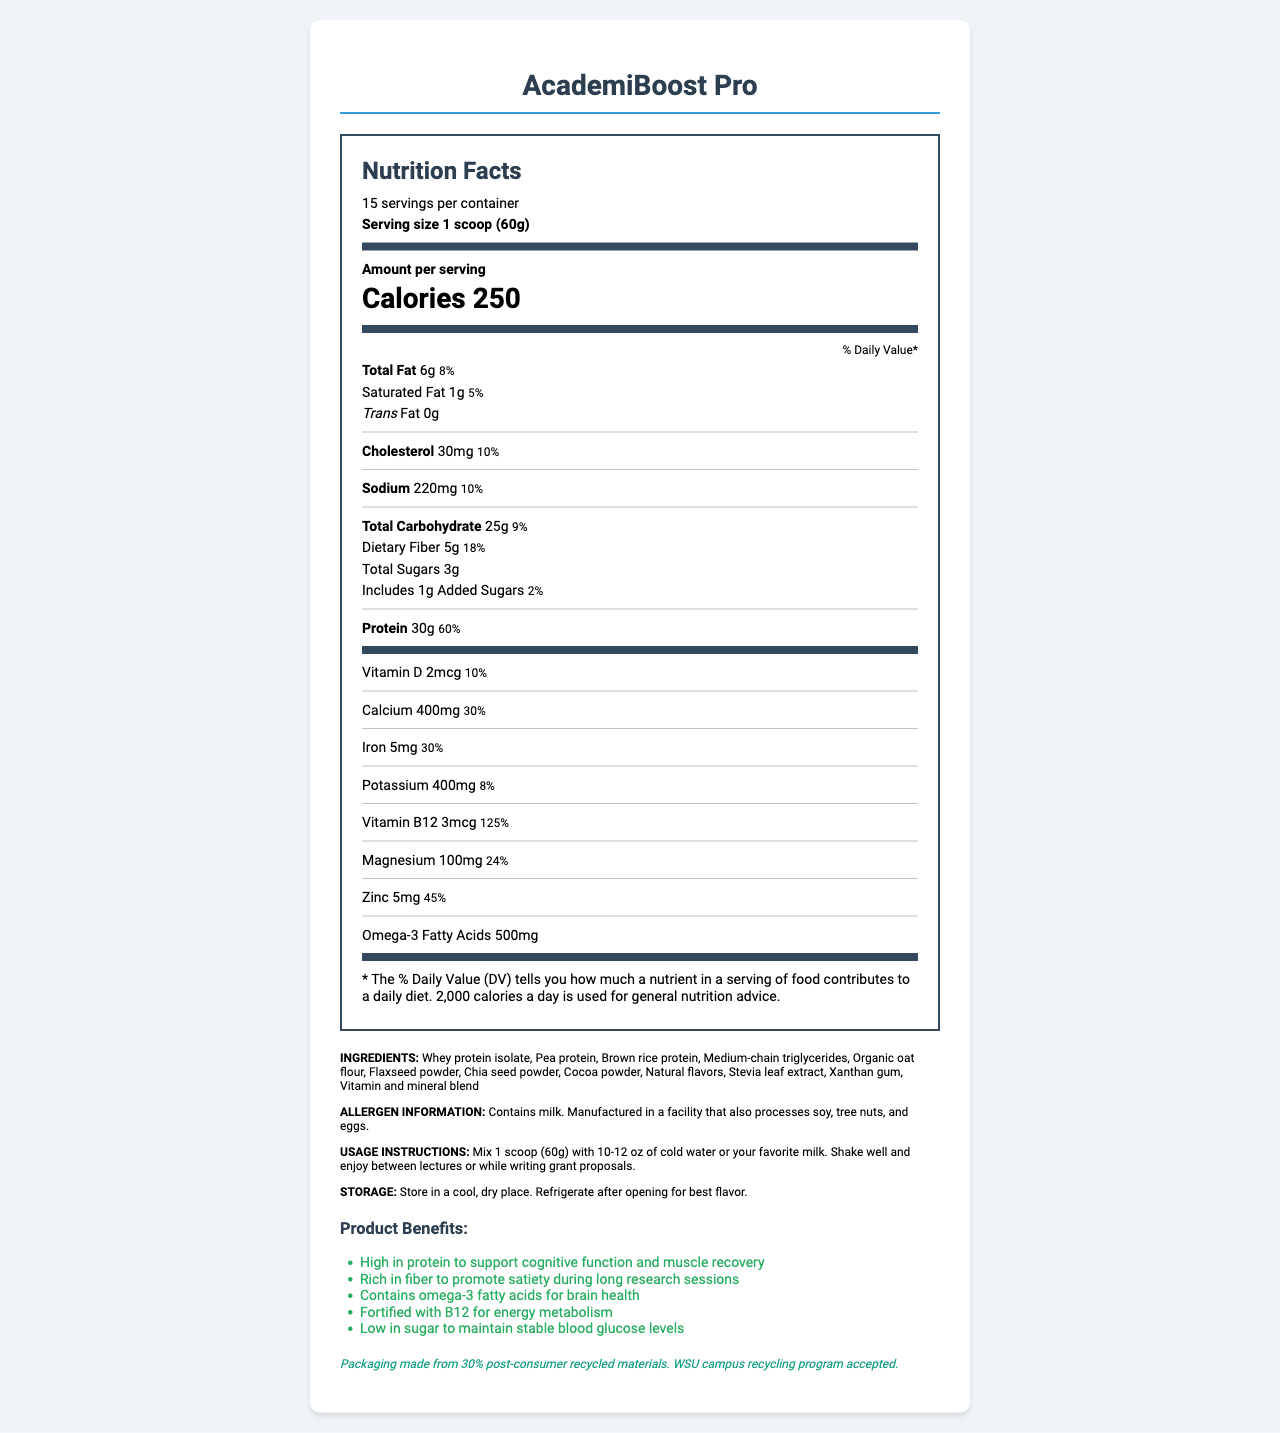what is the serving size of AcademiBoost Pro? The serving size is stated as "1 scoop (60g)" on the Nutrition Facts Label.
Answer: 1 scoop (60g) how many servings are there per container? The document mentions that there are 15 servings per container.
Answer: 15 servings per container how many calories are there per serving? The amount per serving is indicated as 250 calories.
Answer: 250 calories what is the amount of protein per serving and its daily value percentage? The label shows that each serving has 30g of protein, which is 60% of the daily value.
Answer: 30g, 60% which vitamin has the highest daily value percentage in a serving? The Nutrition Facts Label shows Vitamin B12 at 125% daily value, the highest among listed vitamins.
Answer: Vitamin B12 contains milk. Manufactured in a facility that also processes which allergens? A. Shellfish, Wheat, Eggs B. Soy, Shellfish, Milk C. Soy, Tree nuts, Eggs The label indicates "Contains milk. Manufactured in a facility that also processes soy, tree nuts, and eggs."
Answer: C what amount of added sugars does one serving contain? According to the Nutrition Facts Label, there is 1g of added sugars per serving.
Answer: 1g which ingredient is not present in AcademiBoost Pro? A. Flaxseed powder B. Almond milk C. Pea protein Almond milk is not listed among the ingredients, but Flaxseed powder and Pea protein are included.
Answer: B is AcademiBoost Pro fortified with Vitamin D? The document lists Vitamin D as one of the vitamins, with a daily value of 10%.
Answer: Yes describe the main benefits of AcademiBoost Pro for busy academics. The document outlines several main benefits, including high protein for cognitive function and muscle recovery, fiber for satiety, omega-3s for brain health, B12 for energy, and low sugar for stable blood glucose.
Answer: AcademiBoost Pro is high in protein to support cognitive function and muscle recovery, rich in fiber to promote satiety, contains omega-3 fatty acids for brain health, fortified with B12 for energy metabolism, and low in sugar to maintain stable blood glucose levels. what is the source of omega-3 fatty acids in AcademiBoost Pro? The document mentions that there are omega-3 fatty acids present but does not specify the source.
Answer: Not enough information how much cholesterol does one serving of AcademiBoost Pro contain? The Nutrition Facts label shows that one serving contains 30mg of cholesterol.
Answer: 30mg what synthetic sweetener is used in AcademiBoost Pro? The ingredient list includes Stevia leaf extract, a natural sweetener, but does not indicate any synthetic sweeteners.
Answer: Stevia leaf extract what are the usage instructions for AcademiBoost Pro? The usage instructions provided are to mix 1 scoop (60g) with 10-12 oz of cold water or your favorite milk, shake well, and consume between lectures or while writing grant proposals.
Answer: Mix 1 scoop (60g) with 10-12 oz of cold water or your favorite milk. Shake well and enjoy between lectures or while writing grant proposals. is AcademiBoost Pro suitable for individuals with a tree nut allergy? The document indicates it is manufactured in a facility that processes tree nuts, which may pose allergen concerns.
Answer: No 